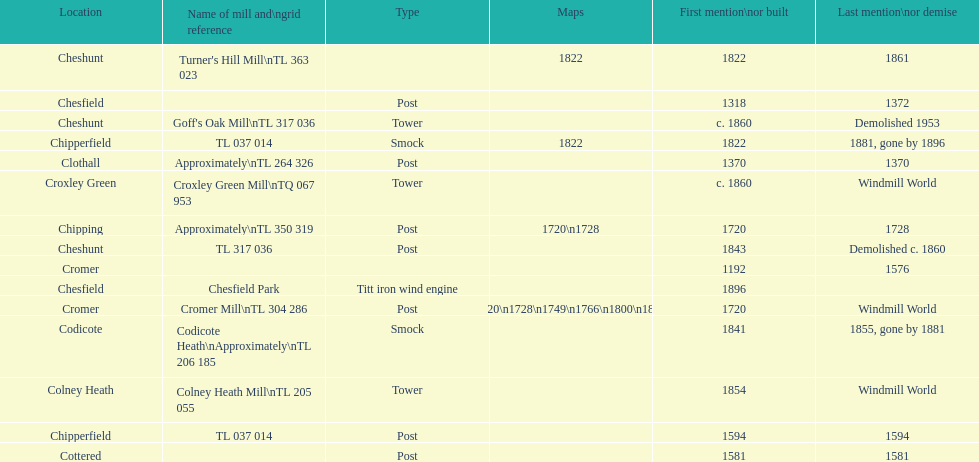Did cromer, chipperfield or cheshunt have the most windmills? Cheshunt. 